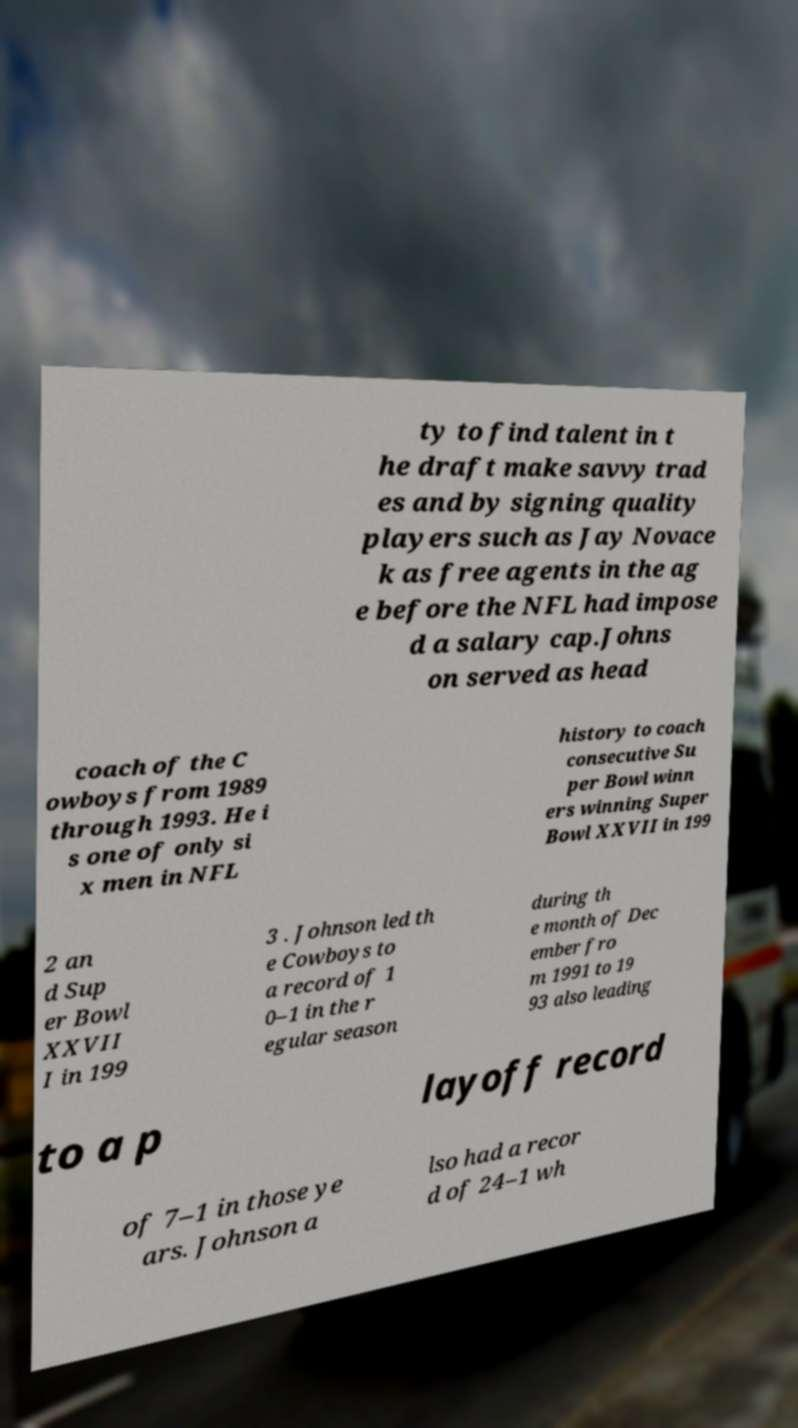I need the written content from this picture converted into text. Can you do that? ty to find talent in t he draft make savvy trad es and by signing quality players such as Jay Novace k as free agents in the ag e before the NFL had impose d a salary cap.Johns on served as head coach of the C owboys from 1989 through 1993. He i s one of only si x men in NFL history to coach consecutive Su per Bowl winn ers winning Super Bowl XXVII in 199 2 an d Sup er Bowl XXVII I in 199 3 . Johnson led th e Cowboys to a record of 1 0–1 in the r egular season during th e month of Dec ember fro m 1991 to 19 93 also leading to a p layoff record of 7–1 in those ye ars. Johnson a lso had a recor d of 24–1 wh 